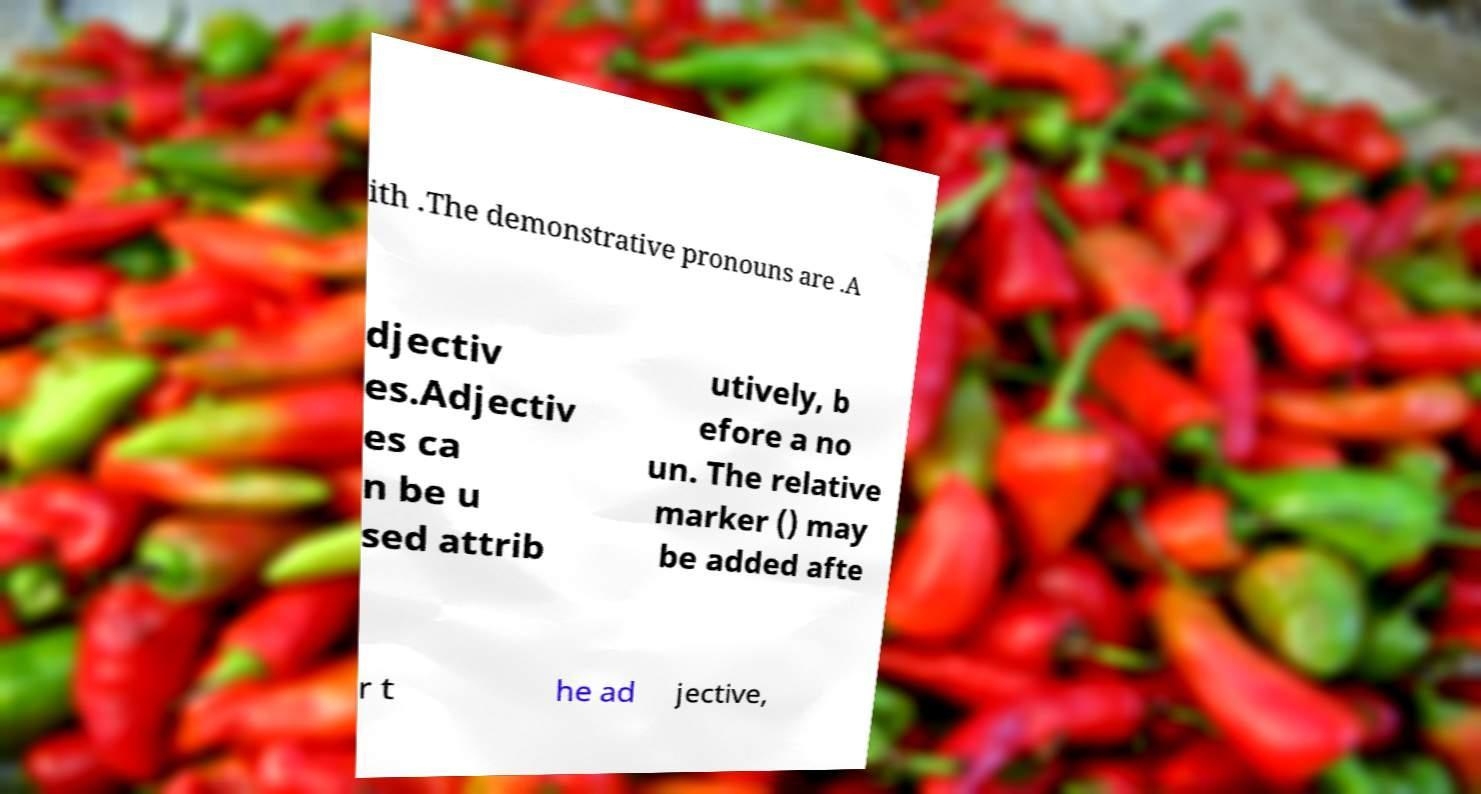What messages or text are displayed in this image? I need them in a readable, typed format. ith .The demonstrative pronouns are .A djectiv es.Adjectiv es ca n be u sed attrib utively, b efore a no un. The relative marker () may be added afte r t he ad jective, 